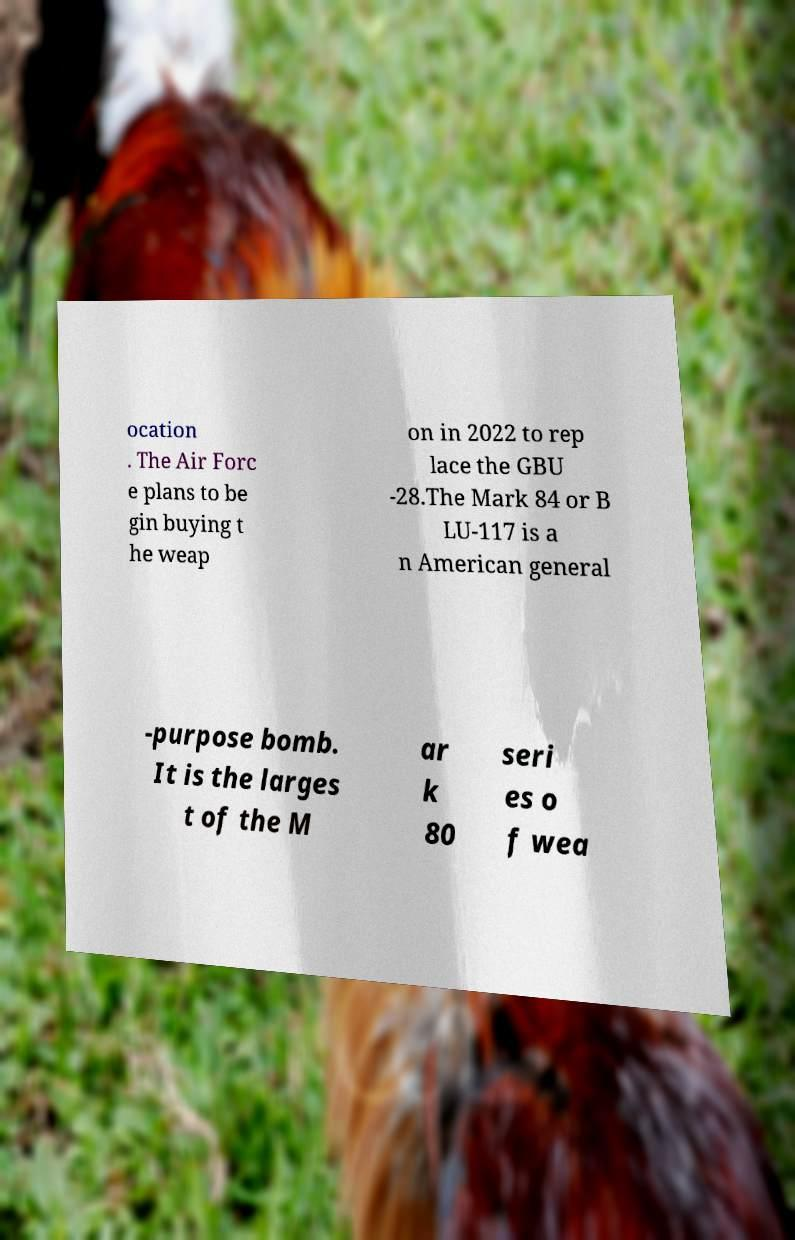There's text embedded in this image that I need extracted. Can you transcribe it verbatim? ocation . The Air Forc e plans to be gin buying t he weap on in 2022 to rep lace the GBU -28.The Mark 84 or B LU-117 is a n American general -purpose bomb. It is the larges t of the M ar k 80 seri es o f wea 